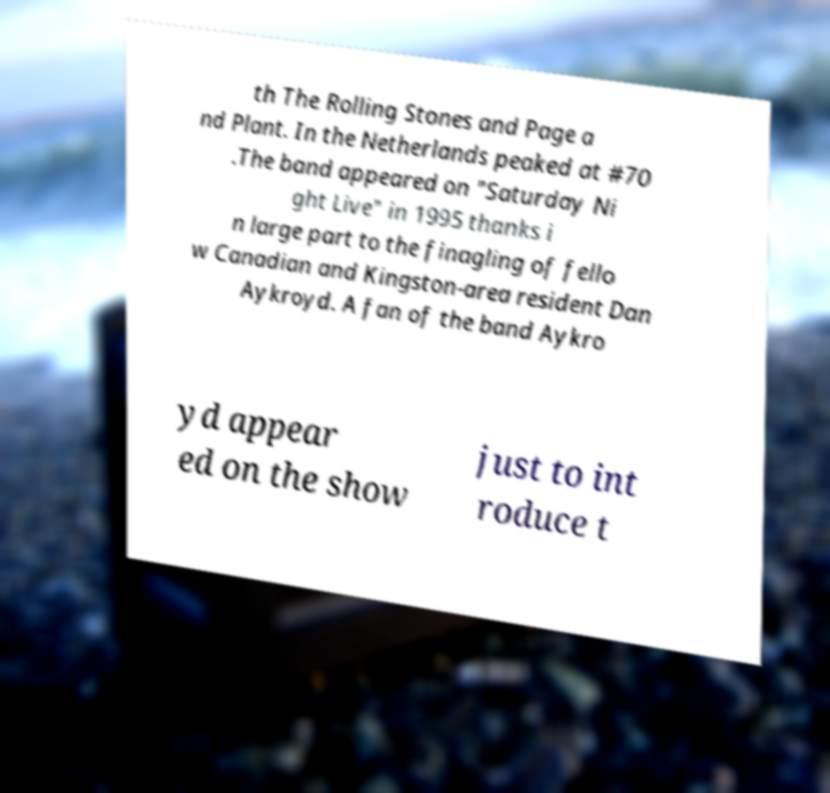Could you assist in decoding the text presented in this image and type it out clearly? th The Rolling Stones and Page a nd Plant. In the Netherlands peaked at #70 .The band appeared on "Saturday Ni ght Live" in 1995 thanks i n large part to the finagling of fello w Canadian and Kingston-area resident Dan Aykroyd. A fan of the band Aykro yd appear ed on the show just to int roduce t 